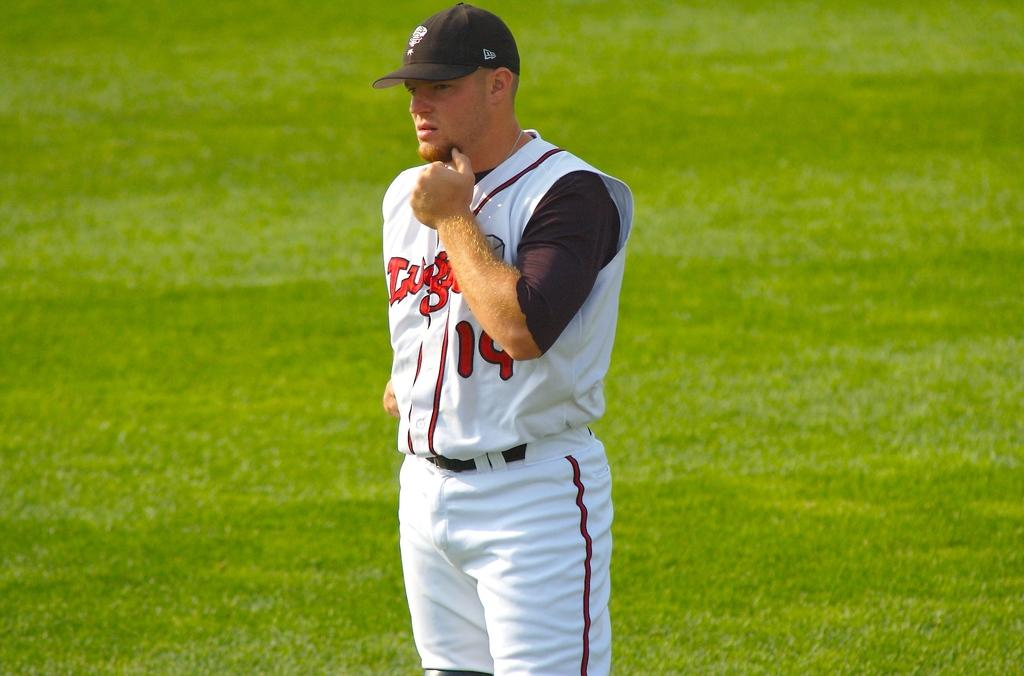<image>
Present a compact description of the photo's key features. a man with a shirt that has 14 on it 